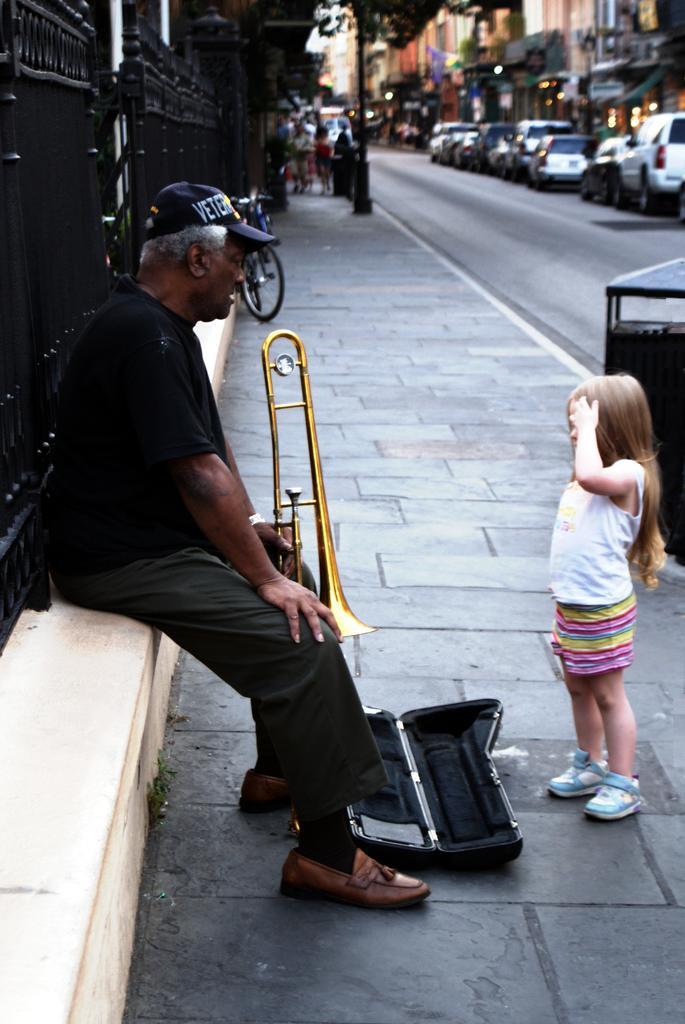In one or two sentences, can you explain what this image depicts? In this image we can see group of persons. One man wearing a black dress and a cap is holding a musical instrument in his hand and sitting on the wall. To the right side of the image we can see a child standing on the ground wearing a white dress. In the background, we can see a metal barricade, a group of vehicles parked on the road, a group of buildings, pokes and a bicycle parked on the path. 